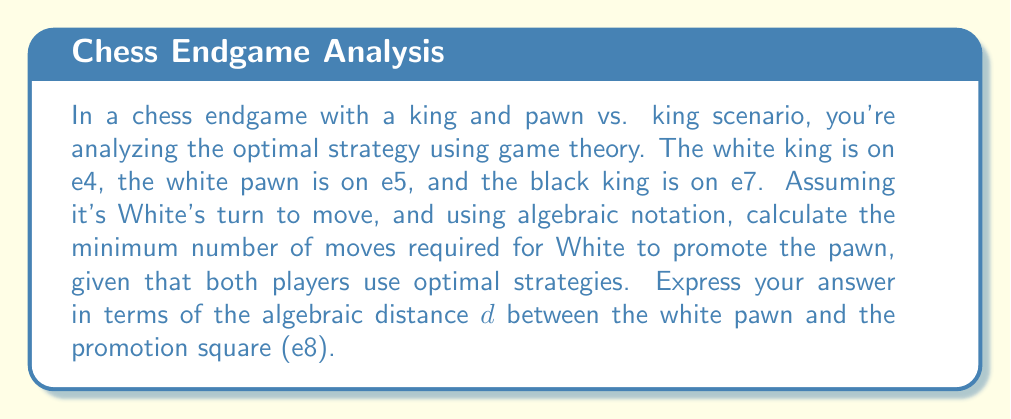Give your solution to this math problem. To solve this problem, we'll use game theory concepts and algebraic notation:

1) First, we need to understand the optimal strategy for White:
   - Move the king to support the pawn's advance
   - Advance the pawn when it's safe to do so

2) The optimal strategy for Black is to block the pawn's path with the king.

3) Given the initial position:
   - White King: e4
   - White Pawn: e5
   - Black King: e7

4) The algebraic distance $d$ between the white pawn (e5) and the promotion square (e8) is 3.

5) To promote the pawn, White needs to:
   a) Move the king to f6 to support the pawn (2 moves)
   b) Advance the pawn $d$ times

6) The total number of moves can be expressed as:
   $$2 + d$$

7) However, Black will try to block the pawn. In the worst case for White, Black can force White to make an extra move with the king for each pawn advance.

8) Therefore, the minimum number of moves required is:
   $$2 + 2d$$

This formula accounts for:
- 2 initial moves to get the white king to f6
- $d$ moves to advance the pawn
- $d$ additional moves with the king to support each pawn advance
Answer: $2 + 2d$ 